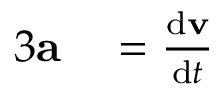<formula> <loc_0><loc_0><loc_500><loc_500>\begin{array} { r l } { { 3 } a } & = { \frac { d v } { d t } } } \end{array}</formula> 